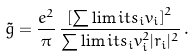Convert formula to latex. <formula><loc_0><loc_0><loc_500><loc_500>\tilde { g } = \frac { e ^ { 2 } } { \pi } \, \frac { \left [ \sum \lim i t s _ { i } v _ { i } \right ] ^ { 2 } } { \sum \lim i t s _ { i } v _ { i } ^ { 2 } | r _ { i } | ^ { 2 } } \, .</formula> 